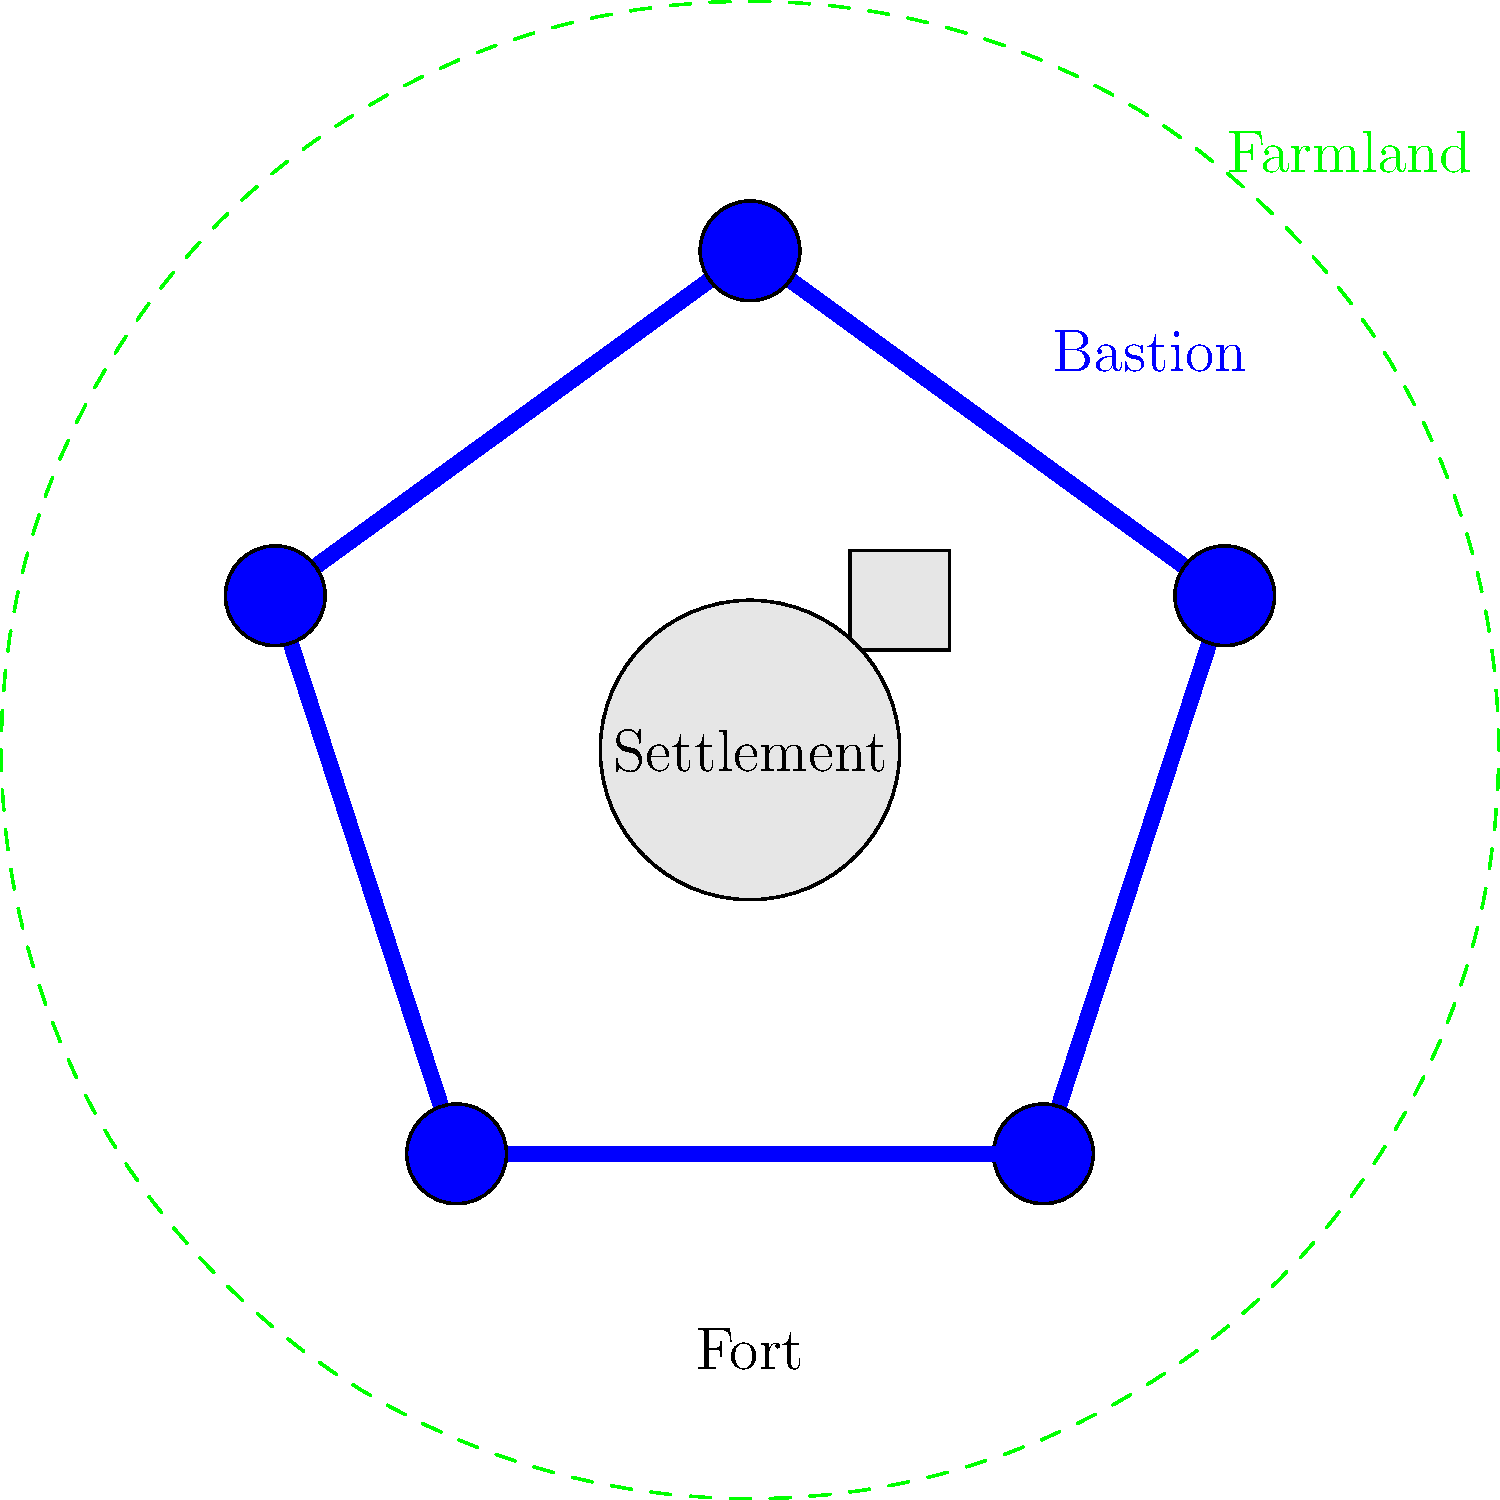Examine the bird's-eye view map of a colonial fort settlement. How does the layout of this fort demonstrate the defensive strategies employed by European colonizers in their overseas territories? To answer this question, we need to analyze the key features of the fort's layout:

1. Pentagonal shape: The fort has a pentagonal outline, which was a common design in European fortifications. This shape allowed for better distribution of defensive fire and reduced blind spots.

2. Bastions: At each corner of the pentagon, there are circular structures representing bastions. These protruding structures allowed defenders to have a wide field of fire along the walls, creating overlapping fields of fire and eliminating dead zones.

3. Thick walls: The blue lines represent thick walls, which were essential for protection against artillery fire and scaling attempts.

4. Central settlement: Inside the fort, we see buildings representing the settlement. This centralized layout provided protection for colonists and important structures.

5. Surrounding farmland: The dashed green circle represents farmland outside the fort. This shows how the fort served as a center of colonial activity, protecting agricultural resources.

6. Single entrance (implied): Although not explicitly shown, most forts had a single, well-defended entrance, which was easier to protect than multiple entry points.

This layout demonstrates several key defensive strategies:
- Use of geometric designs for optimal defense
- Incorporation of bastions for improved firing angles
- Protection of settlers and resources within thick walls
- Control over surrounding agricultural areas

These elements reflect the European approach to colonial fortifications, emphasizing protection, control, and the establishment of a power center in foreign territories.
Answer: Pentagonal layout with bastions, thick walls, and centralized settlement for optimal defense and resource protection. 